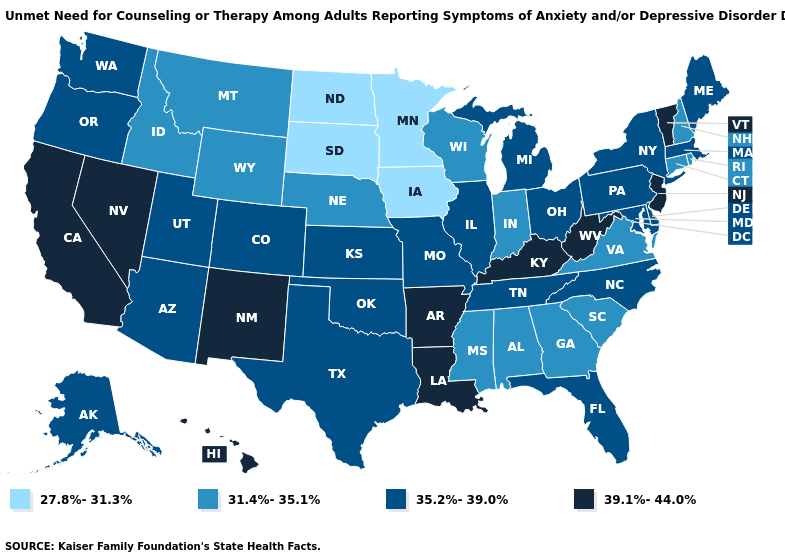Name the states that have a value in the range 35.2%-39.0%?
Concise answer only. Alaska, Arizona, Colorado, Delaware, Florida, Illinois, Kansas, Maine, Maryland, Massachusetts, Michigan, Missouri, New York, North Carolina, Ohio, Oklahoma, Oregon, Pennsylvania, Tennessee, Texas, Utah, Washington. Does Michigan have the highest value in the MidWest?
Keep it brief. Yes. Does Indiana have the same value as Louisiana?
Keep it brief. No. What is the value of Rhode Island?
Give a very brief answer. 31.4%-35.1%. Name the states that have a value in the range 27.8%-31.3%?
Answer briefly. Iowa, Minnesota, North Dakota, South Dakota. What is the value of Virginia?
Write a very short answer. 31.4%-35.1%. Among the states that border Arkansas , which have the highest value?
Keep it brief. Louisiana. What is the highest value in the USA?
Keep it brief. 39.1%-44.0%. Which states have the lowest value in the USA?
Short answer required. Iowa, Minnesota, North Dakota, South Dakota. Name the states that have a value in the range 39.1%-44.0%?
Give a very brief answer. Arkansas, California, Hawaii, Kentucky, Louisiana, Nevada, New Jersey, New Mexico, Vermont, West Virginia. What is the value of North Dakota?
Be succinct. 27.8%-31.3%. Name the states that have a value in the range 39.1%-44.0%?
Short answer required. Arkansas, California, Hawaii, Kentucky, Louisiana, Nevada, New Jersey, New Mexico, Vermont, West Virginia. Does West Virginia have the lowest value in the USA?
Write a very short answer. No. What is the lowest value in states that border Mississippi?
Answer briefly. 31.4%-35.1%. Name the states that have a value in the range 39.1%-44.0%?
Concise answer only. Arkansas, California, Hawaii, Kentucky, Louisiana, Nevada, New Jersey, New Mexico, Vermont, West Virginia. 